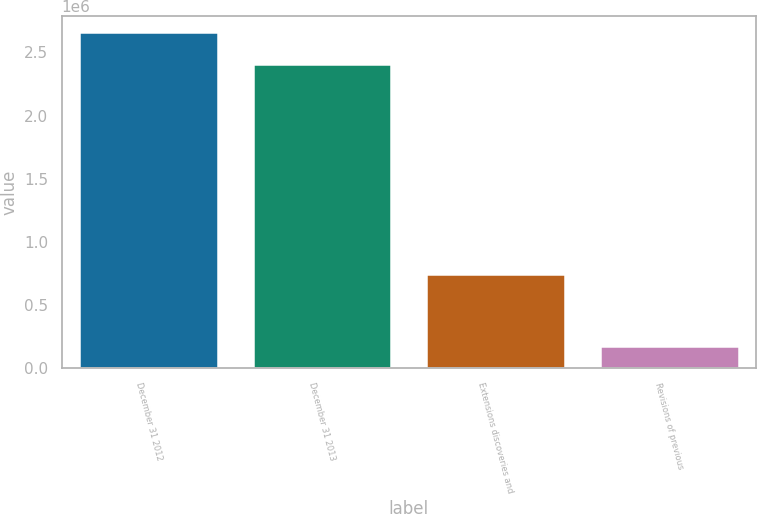<chart> <loc_0><loc_0><loc_500><loc_500><bar_chart><fcel>December 31 2012<fcel>December 31 2013<fcel>Extensions discoveries and<fcel>Revisions of previous<nl><fcel>2.65814e+06<fcel>2.41235e+06<fcel>743212<fcel>173191<nl></chart> 